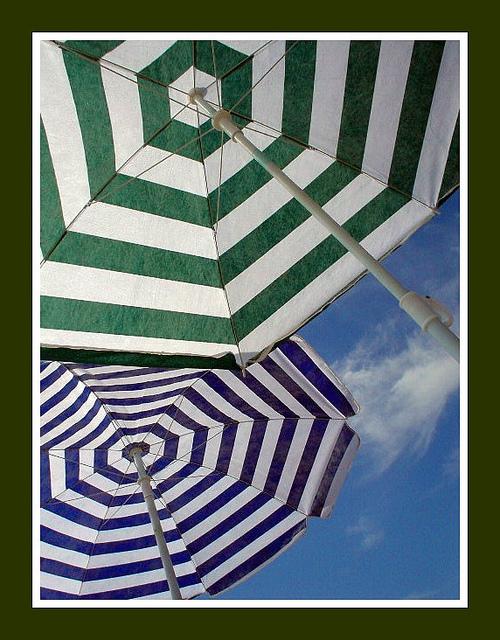What colors are the umbrellas?
Quick response, please. Blue and green. What material is the umbrella pole made of?
Answer briefly. Plastic. Is there clouds in the sky?
Be succinct. Yes. How many umbrellas are seen?
Be succinct. 2. 